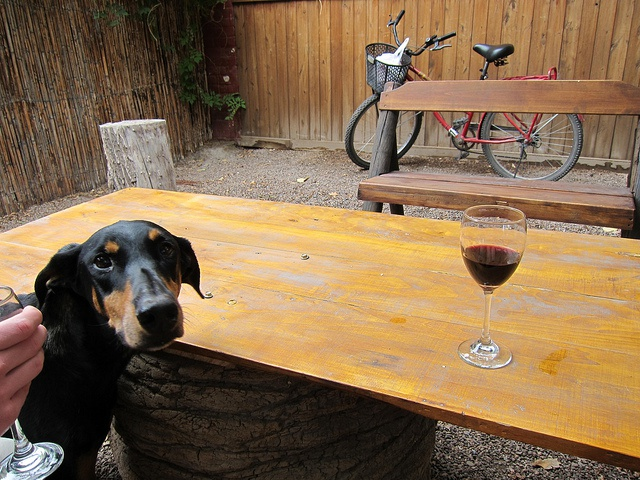Describe the objects in this image and their specific colors. I can see dining table in black, tan, and gold tones, bench in black, gray, tan, and darkgray tones, dog in black, gray, darkgray, and tan tones, bicycle in black, gray, and darkgray tones, and wine glass in black, tan, maroon, and gray tones in this image. 